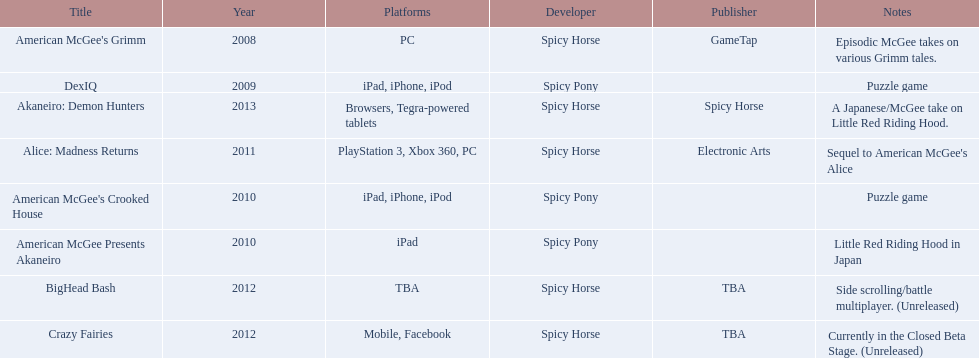What are all the titles? American McGee's Grimm, DexIQ, American McGee Presents Akaneiro, American McGee's Crooked House, Alice: Madness Returns, BigHead Bash, Crazy Fairies, Akaneiro: Demon Hunters. What platforms were they available on? PC, iPad, iPhone, iPod, iPad, iPad, iPhone, iPod, PlayStation 3, Xbox 360, PC, TBA, Mobile, Facebook, Browsers, Tegra-powered tablets. And which were available only on the ipad? American McGee Presents Akaneiro. 